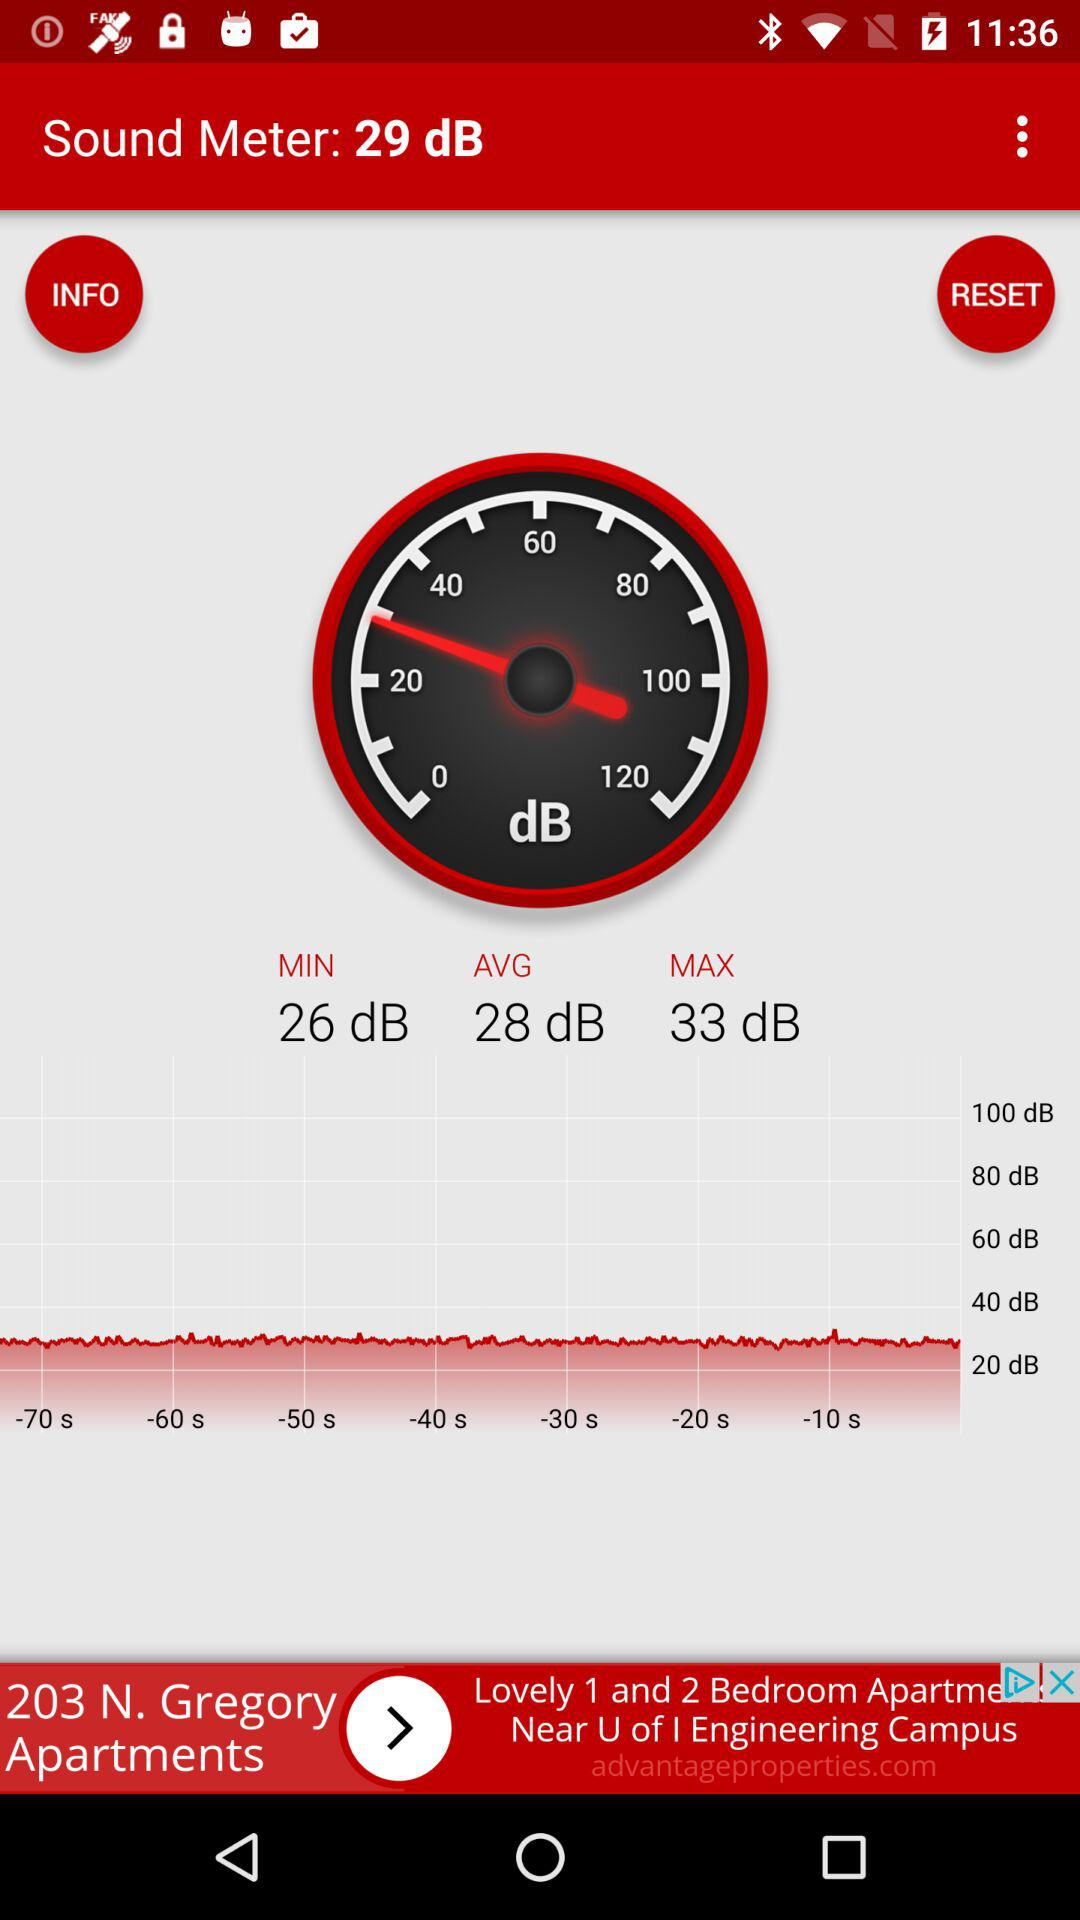What is the difference between the maximum and minimum dB values?
Answer the question using a single word or phrase. 7 dB 